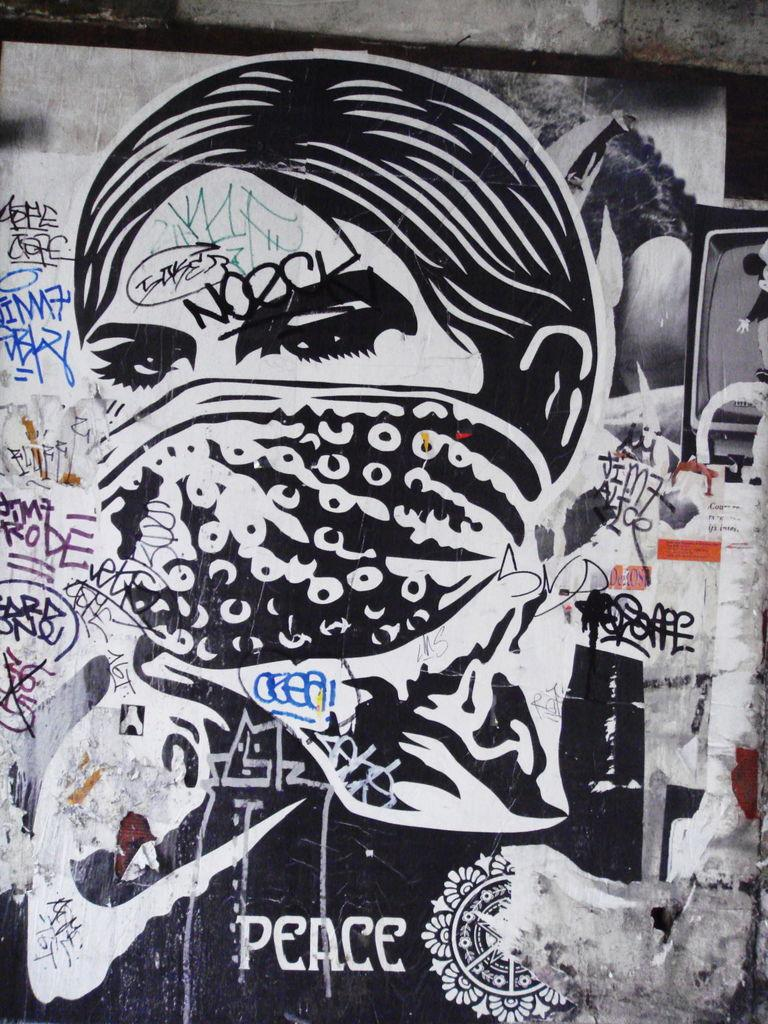What is depicted on the wall in the image? There is a wall with pictures and text painted on it in the image. What is the person in the image doing? The person is wearing a cloth to their face. What can be seen on the right side of the image? There is a television on the right side of the image. What is the television displaying? The television is displaying a cartoon image. Can you tell me how many girls are visible in the image? There is no girl present in the image. Is there a baby playing with bubbles in the image? There is no baby or bubbles present in the image. 